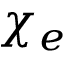<formula> <loc_0><loc_0><loc_500><loc_500>\chi _ { e }</formula> 